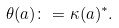<formula> <loc_0><loc_0><loc_500><loc_500>\theta ( a ) \colon = \kappa ( a ) ^ { * } .</formula> 